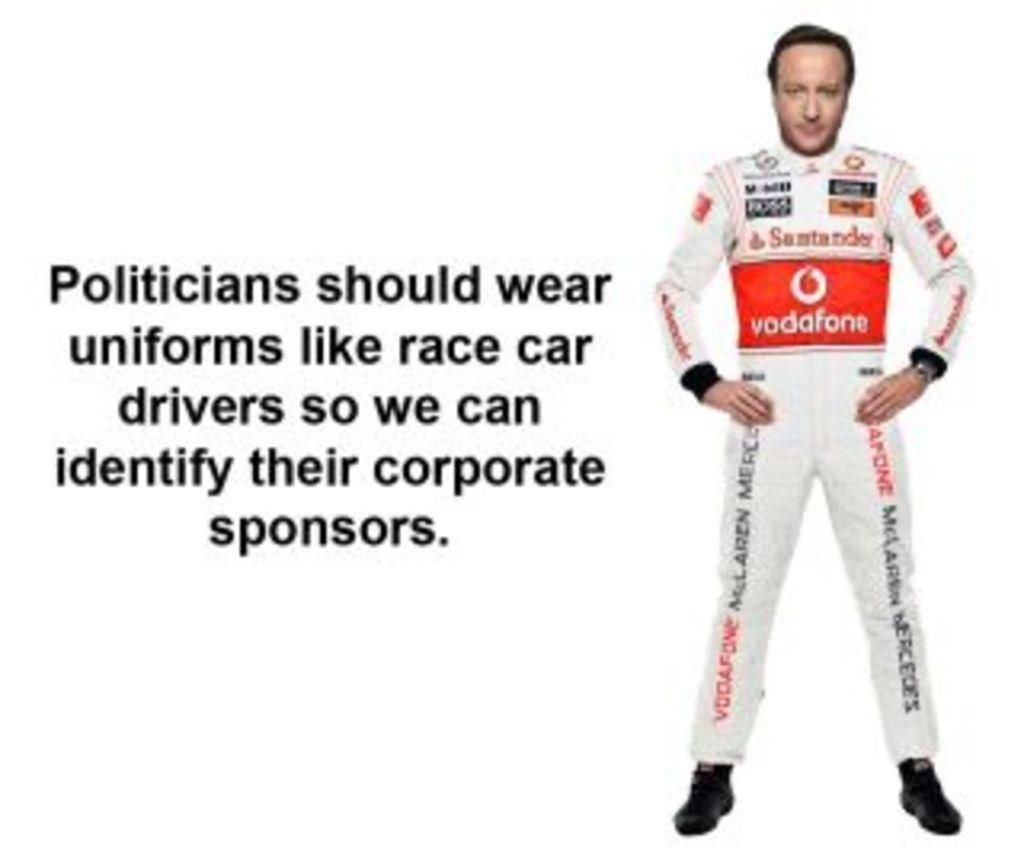Provide a one-sentence caption for the provided image. a man with clothing on that has vodafone written on it. 